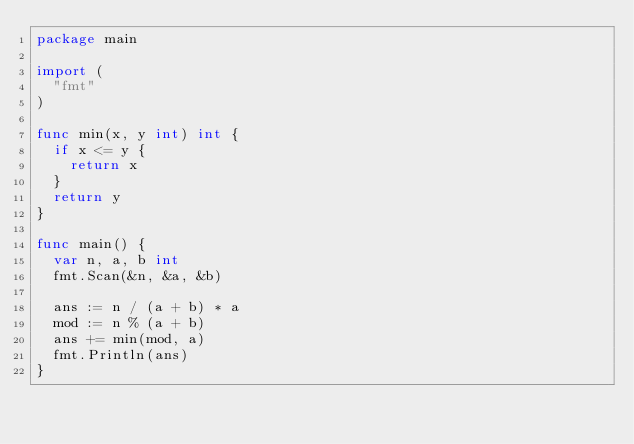Convert code to text. <code><loc_0><loc_0><loc_500><loc_500><_Go_>package main

import (
	"fmt"
)

func min(x, y int) int {
	if x <= y {
		return x
	}
	return y
}

func main() {
	var n, a, b int
	fmt.Scan(&n, &a, &b)

	ans := n / (a + b) * a
	mod := n % (a + b)
	ans += min(mod, a)
	fmt.Println(ans)
}
</code> 